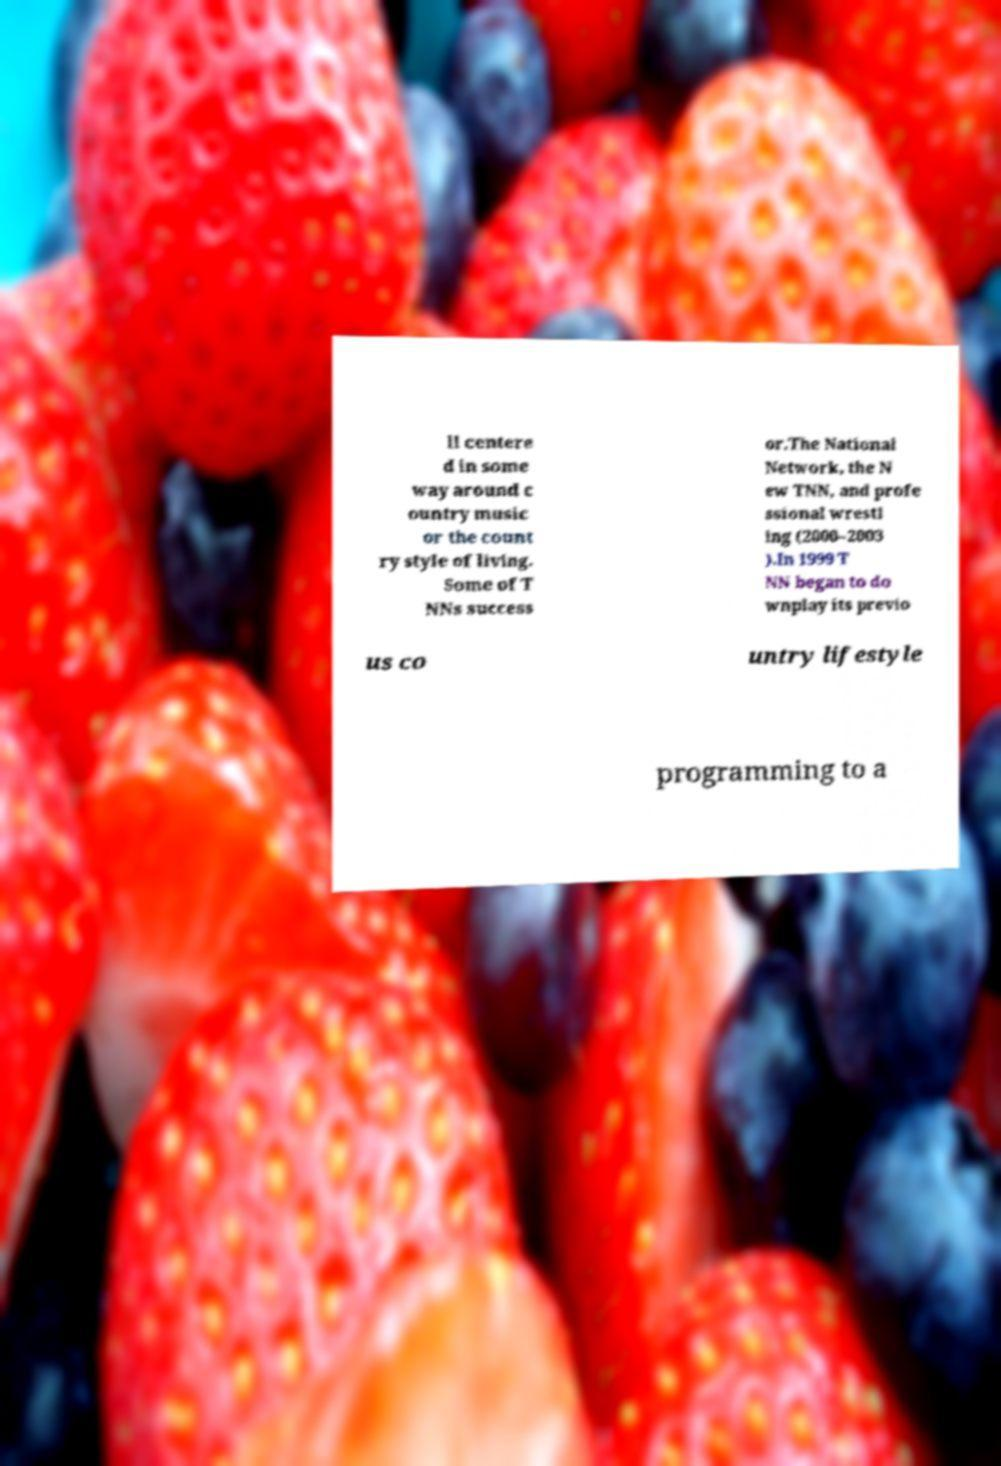Could you extract and type out the text from this image? ll centere d in some way around c ountry music or the count ry style of living. Some of T NNs success or.The National Network, the N ew TNN, and profe ssional wrestl ing (2000–2003 ).In 1999 T NN began to do wnplay its previo us co untry lifestyle programming to a 